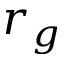Convert formula to latex. <formula><loc_0><loc_0><loc_500><loc_500>r _ { g }</formula> 